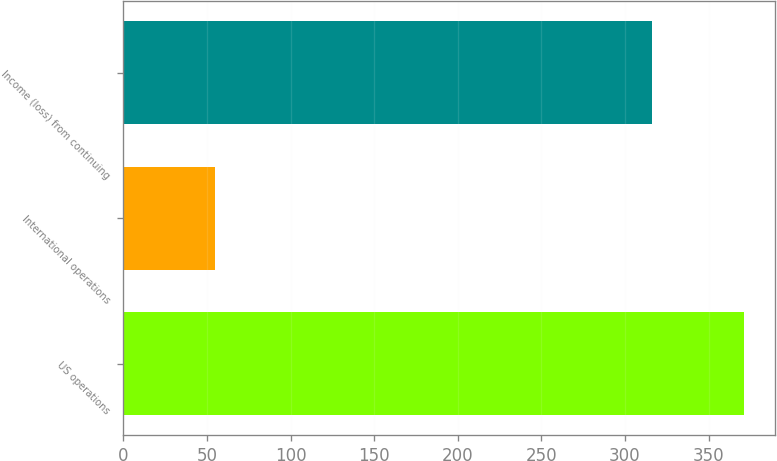Convert chart. <chart><loc_0><loc_0><loc_500><loc_500><bar_chart><fcel>US operations<fcel>International operations<fcel>Income (loss) from continuing<nl><fcel>371<fcel>55<fcel>316<nl></chart> 